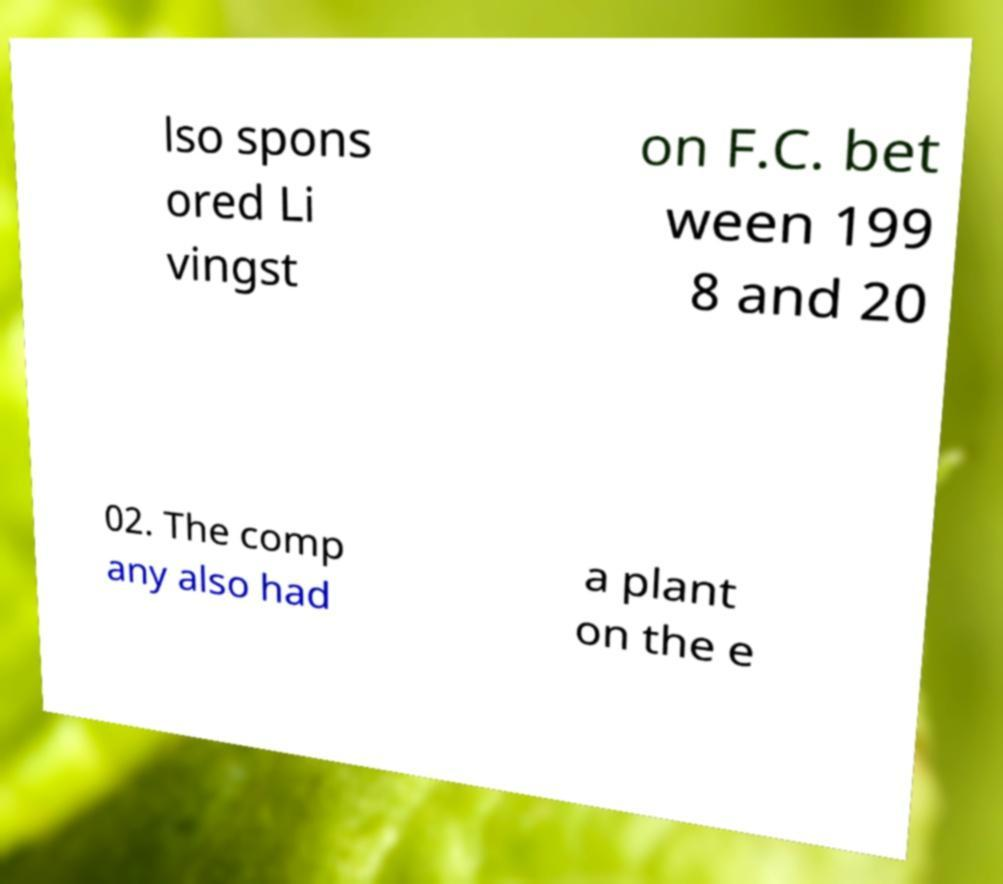Can you read and provide the text displayed in the image?This photo seems to have some interesting text. Can you extract and type it out for me? lso spons ored Li vingst on F.C. bet ween 199 8 and 20 02. The comp any also had a plant on the e 